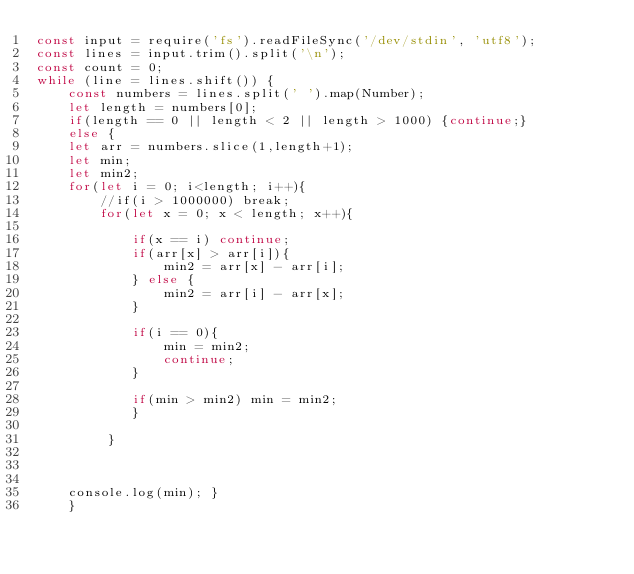Convert code to text. <code><loc_0><loc_0><loc_500><loc_500><_JavaScript_>const input = require('fs').readFileSync('/dev/stdin', 'utf8');
const lines = input.trim().split('\n');
const count = 0;
while (line = lines.shift()) {
    const numbers = lines.split(' ').map(Number);
    let length = numbers[0];
    if(length == 0 || length < 2 || length > 1000) {continue;}
    else {
    let arr = numbers.slice(1,length+1);
    let min; 
    let min2;
    for(let i = 0; i<length; i++){
        //if(i > 1000000) break;
        for(let x = 0; x < length; x++){
            
            if(x == i) continue;
            if(arr[x] > arr[i]){
                min2 = arr[x] - arr[i];
            } else {
                min2 = arr[i] - arr[x];
            }
        
            if(i == 0){
                min = min2;
                continue;
            } 
        
            if(min > min2) min = min2;
            }
        
         }
    


    console.log(min); }
    }
</code> 